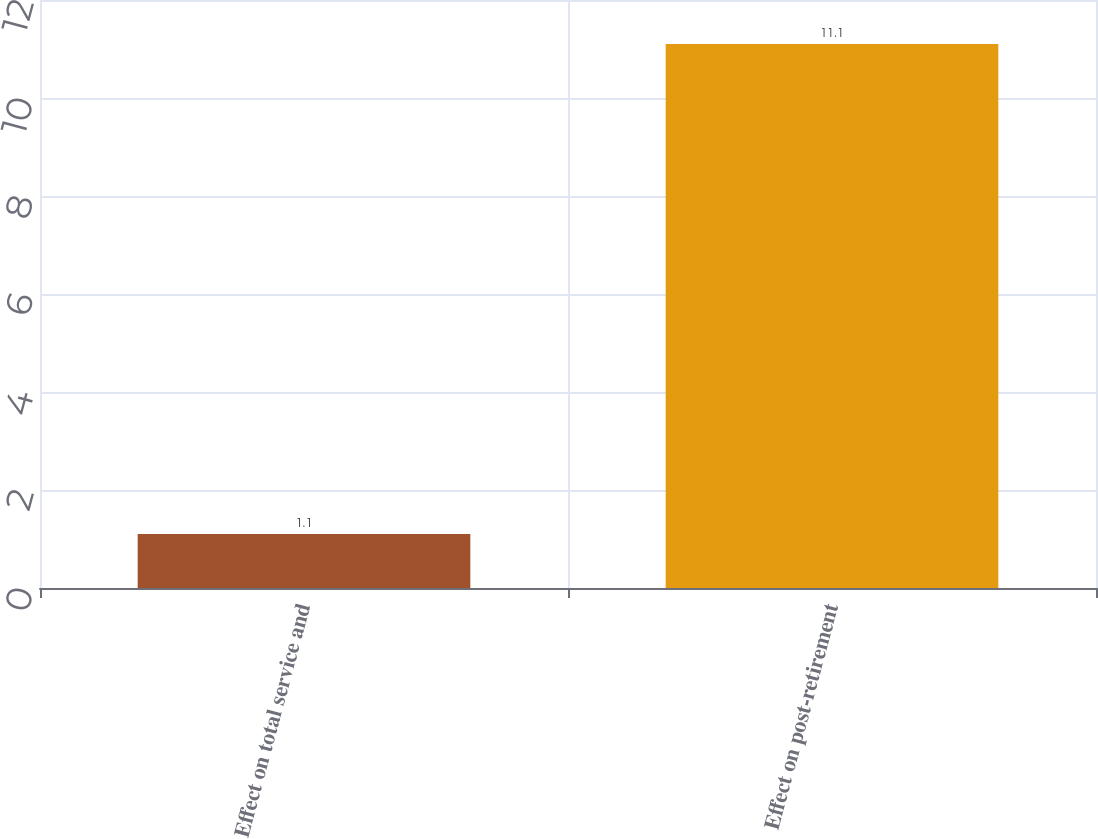<chart> <loc_0><loc_0><loc_500><loc_500><bar_chart><fcel>Effect on total service and<fcel>Effect on post-retirement<nl><fcel>1.1<fcel>11.1<nl></chart> 